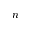Convert formula to latex. <formula><loc_0><loc_0><loc_500><loc_500>n</formula> 